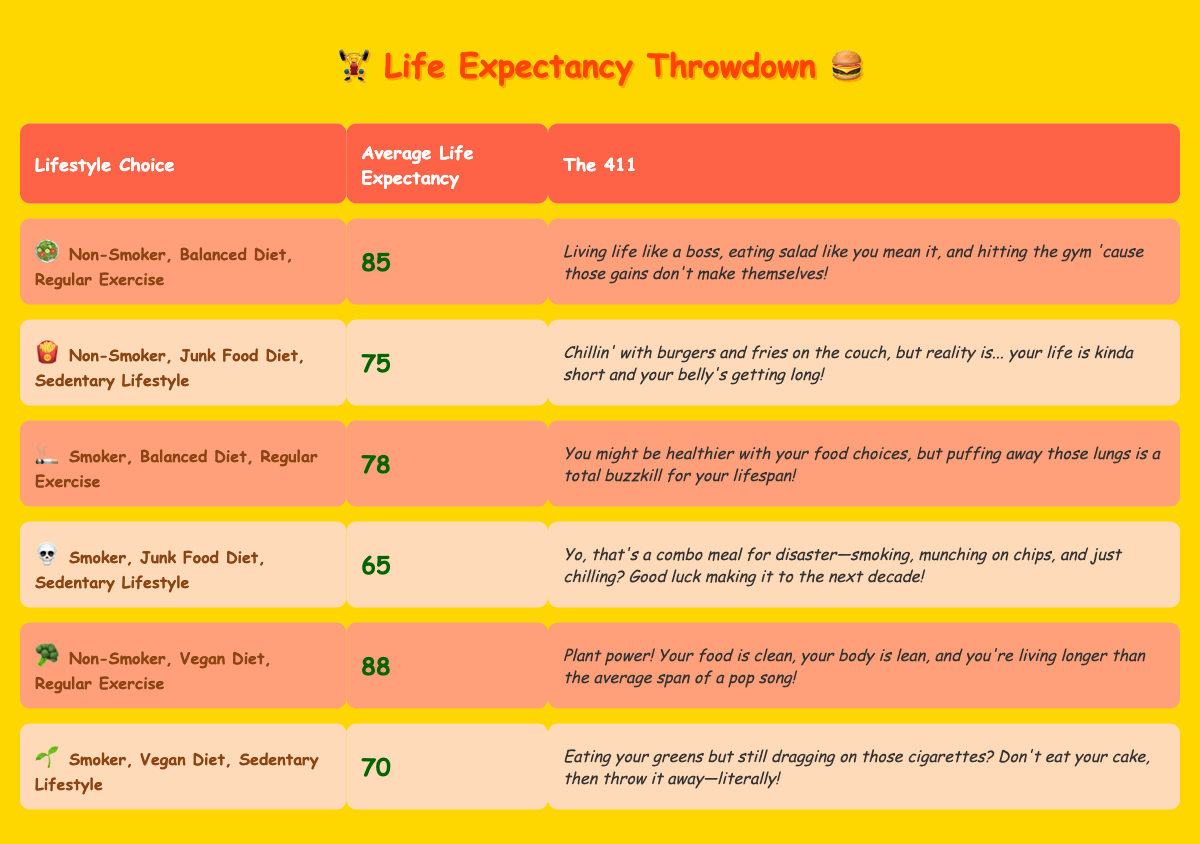What is the average life expectancy for a non-smoker with a balanced diet and regular exercise? The table shows that for a non-smoker with a balanced diet and regular exercise, the average life expectancy is 85 years.
Answer: 85 Which lifestyle choice has the lowest average life expectancy? By comparing the average life expectancy values in the table, the lifestyle choice "Smoker, Junk Food Diet, Sedentary Lifestyle" has the lowest average life expectancy of 65 years.
Answer: 65 Is the average life expectancy of a smoker with a balanced diet and regular exercise higher than that of a non-smoker with a junk food diet and a sedentary lifestyle? The average life expectancy for a "Smoker, Balanced Diet, Regular Exercise" is 78 years, while for a "Non-Smoker, Junk Food Diet, Sedentary Lifestyle," it's 75 years. Since 78 is greater than 75, the statement is true.
Answer: Yes What is the difference in life expectancy between a non-smoker with a vegan diet and regular exercise and a smoker with a vegan diet and a sedentary lifestyle? The non-smoker has an average life expectancy of 88 years, while the smoker has 70 years. Calculating the difference: 88 - 70 = 18 years.
Answer: 18 How many lifestyle choices have an average life expectancy of 75 years or longer? By examining the table, the lifestyle choices with life expectancy 75 years or longer are: "Non-Smoker, Balanced Diet, Regular Exercise" (85 years), "Non-Smoker, Junk Food Diet, Sedentary Lifestyle" (75 years), "Smoker, Balanced Diet, Regular Exercise" (78 years), "Non-Smoker, Vegan Diet, Regular Exercise" (88 years), and "Smoker, Vegan Diet, Sedentary Lifestyle" (70 years). Counting these, there are 5 choices.
Answer: 5 Is it true that all lifestyle choices involving smoking have an average life expectancy of less than 80 years? Checking the table, "Smoker, Balanced Diet, Regular Exercise" has an average life expectancy of 78 years, but "Smoker, Vegan Diet, Sedentary Lifestyle" has 70 years, which confirms that not all smoking choices fall below 80 years. Therefore, the statement is false.
Answer: No What is the average life expectancy for individuals who follow a regular exercise routine, regardless of smoking or diet? There are three lifestyle choices in the table that include regular exercise: "Non-Smoker, Balanced Diet" (85 years), "Smoker, Balanced Diet" (78 years), and "Non-Smoker, Vegan Diet" (88 years). Adding these gives 85 + 78 + 88 = 251. To find the average: 251 / 3 = 83.67, which rounds to 84 years.
Answer: 84 If someone switches from a junk food diet and a sedentary lifestyle to a balanced diet and regular exercise, how much can they potentially increase their life expectancy? Comparing "Non-Smoker, Junk Food Diet, Sedentary Lifestyle" (75 years) and "Non-Smoker, Balanced Diet, Regular Exercise" (85 years), the potential increase is: 85 - 75 = 10 years.
Answer: 10 